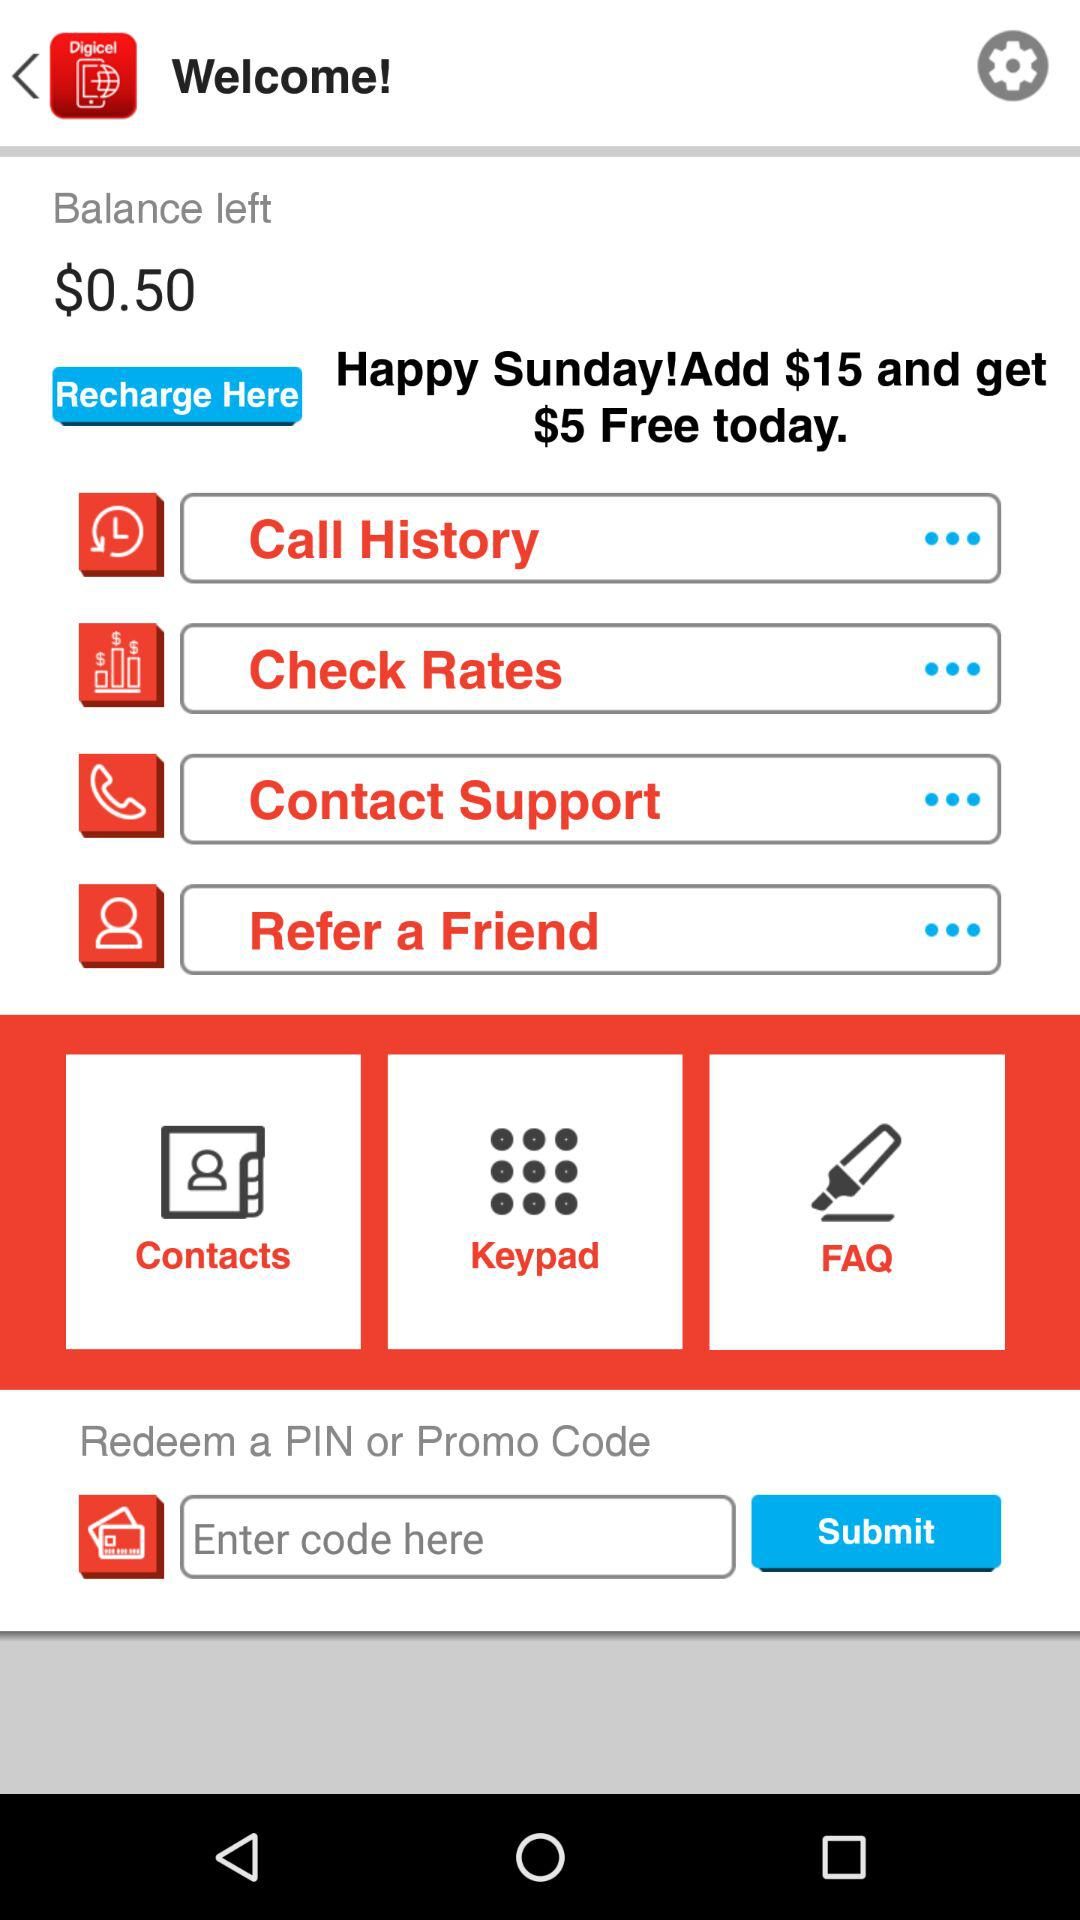How much do I get free on adding $15? You get $5 free when you add $15. 